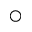<formula> <loc_0><loc_0><loc_500><loc_500>\bigcirc</formula> 